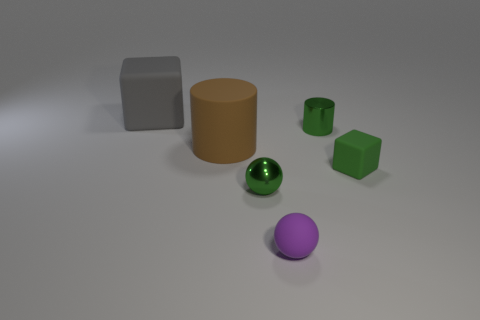Add 3 big brown metal blocks. How many objects exist? 9 Subtract all cylinders. How many objects are left? 4 Add 5 matte blocks. How many matte blocks are left? 7 Add 3 small green spheres. How many small green spheres exist? 4 Subtract 0 gray spheres. How many objects are left? 6 Subtract all purple spheres. Subtract all small green cylinders. How many objects are left? 4 